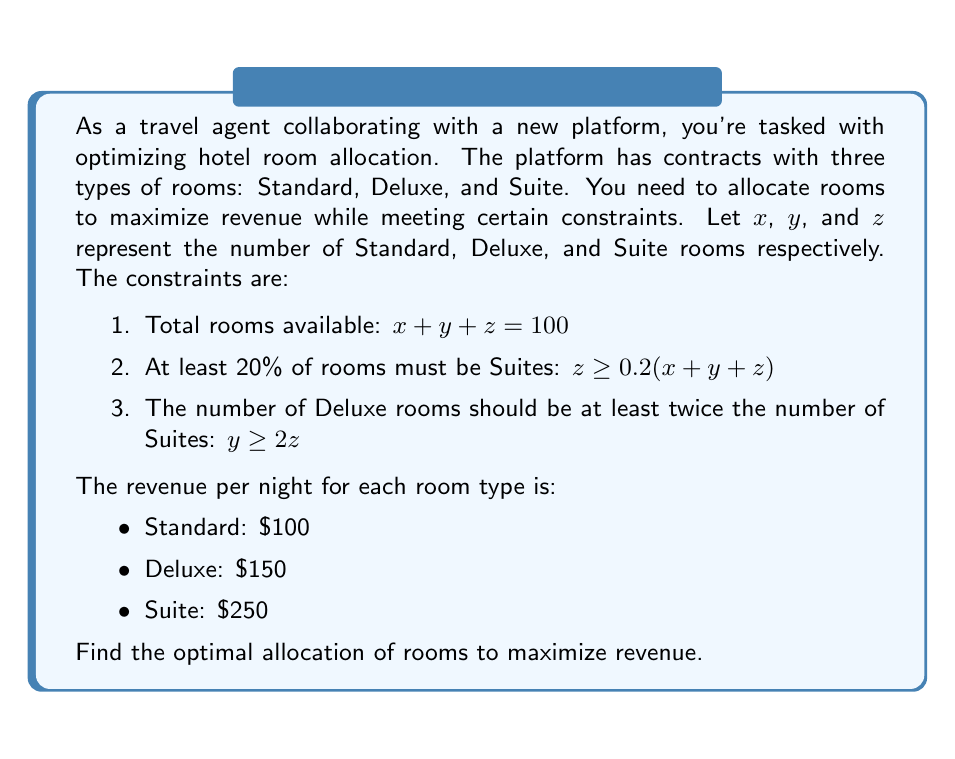Can you solve this math problem? Let's approach this step-by-step:

1) First, we need to set up our objective function. We want to maximize revenue, so:
   
   Revenue = $100x + 150y + 250z$

2) Now, let's rewrite our constraints in standard form:
   
   a) $x + y + z = 100$
   b) $-0.2x - 0.2y + 0.8z \geq 0$
   c) $y - 2z \geq 0$

3) We can solve this using the simplex method, but for this problem, we can also use substitution and reasoning.

4) From constraint (a), we know that $x = 100 - y - z$

5) Substituting this into constraint (b):
   
   $-0.2(100 - y - z) - 0.2y + 0.8z \geq 0$
   $-20 + 0.2y + 0.2z - 0.2y + 0.8z \geq 0$
   $-20 + z \geq 0$
   $z \geq 20$

6) From constraint (c), we know that $y \geq 2z$. Since we want to maximize revenue and Deluxe rooms generate more revenue than Standard rooms, we should set $y = 2z$

7) Substituting these back into constraint (a):
   
   $x + 2z + z = 100$
   $x + 3z = 100$

8) We know $z \geq 20$. Let's try $z = 20$:
   
   $x + 3(20) = 100$
   $x = 40$

   This satisfies all constraints.

9) Our allocation is thus:
   - Standard (x): 40 rooms
   - Deluxe (y): 40 rooms (2z = 2*20)
   - Suite (z): 20 rooms

10) The total revenue with this allocation is:
    
    $100(40) + 150(40) + 250(20) = 4000 + 6000 + 5000 = 15000$

This is the optimal allocation as it satisfies all constraints and maximizes revenue.
Answer: Standard: 40, Deluxe: 40, Suite: 20; Revenue: $15000 